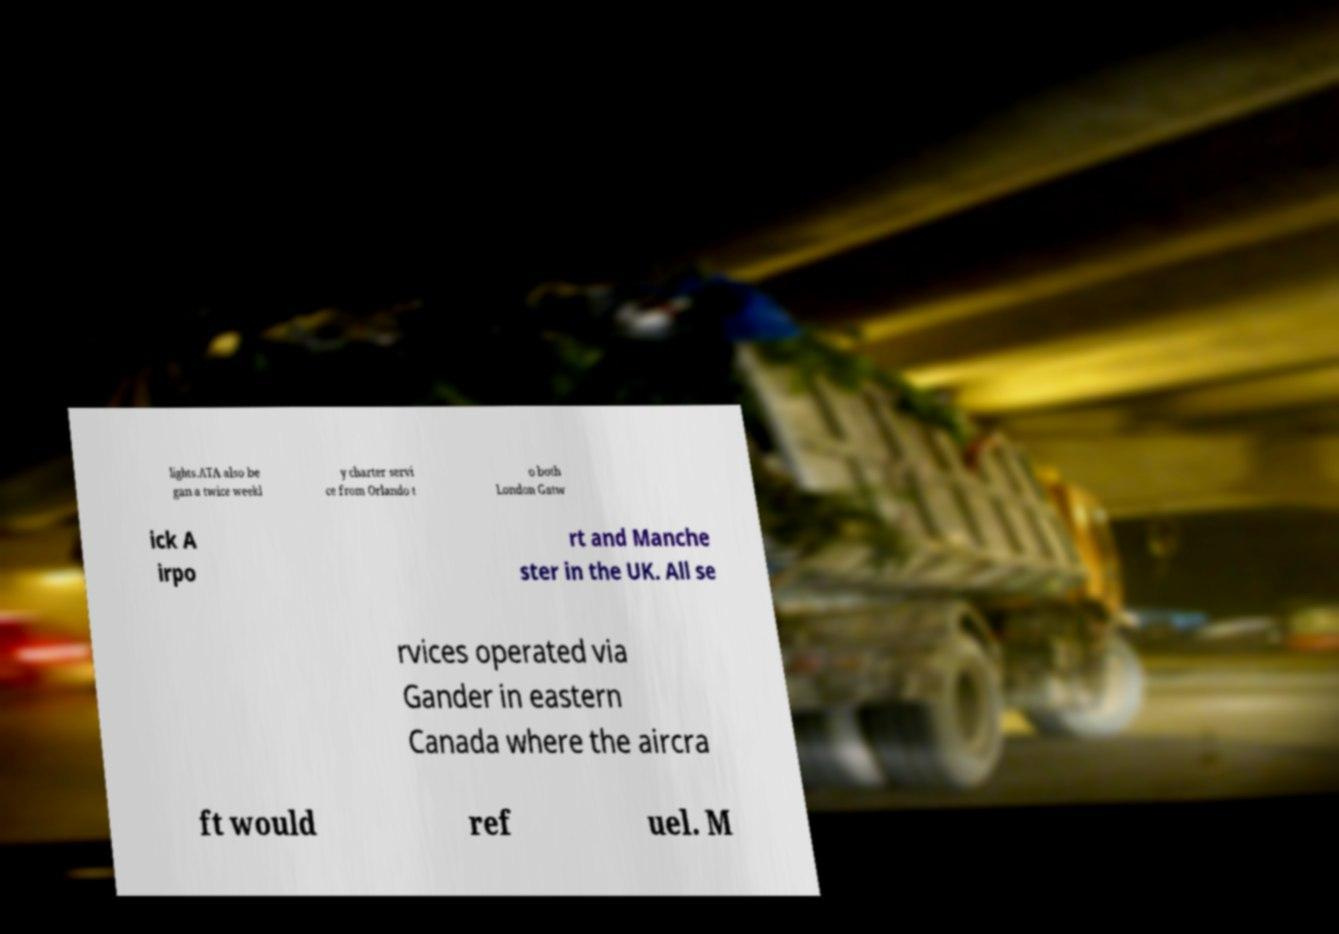I need the written content from this picture converted into text. Can you do that? lights.ATA also be gan a twice weekl y charter servi ce from Orlando t o both London Gatw ick A irpo rt and Manche ster in the UK. All se rvices operated via Gander in eastern Canada where the aircra ft would ref uel. M 